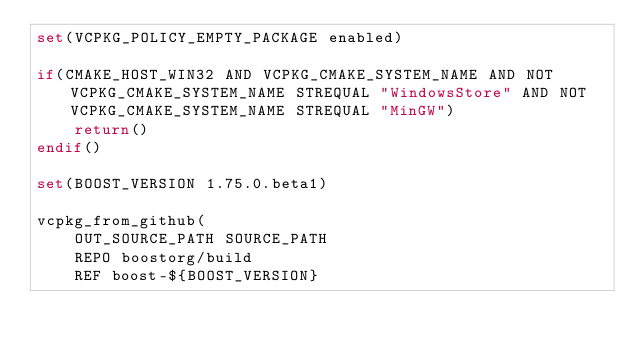<code> <loc_0><loc_0><loc_500><loc_500><_CMake_>set(VCPKG_POLICY_EMPTY_PACKAGE enabled)

if(CMAKE_HOST_WIN32 AND VCPKG_CMAKE_SYSTEM_NAME AND NOT VCPKG_CMAKE_SYSTEM_NAME STREQUAL "WindowsStore" AND NOT VCPKG_CMAKE_SYSTEM_NAME STREQUAL "MinGW")
    return()
endif()

set(BOOST_VERSION 1.75.0.beta1)

vcpkg_from_github(
    OUT_SOURCE_PATH SOURCE_PATH
    REPO boostorg/build
    REF boost-${BOOST_VERSION}</code> 